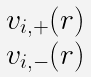Convert formula to latex. <formula><loc_0><loc_0><loc_500><loc_500>\begin{matrix} v _ { i , + } ( r ) \\ v _ { i , - } ( r ) \end{matrix}</formula> 